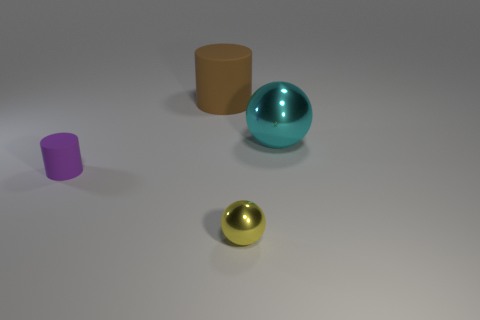There is another rubber object that is the same shape as the brown rubber thing; what size is it?
Provide a short and direct response. Small. There is another ball that is made of the same material as the cyan sphere; what color is it?
Offer a terse response. Yellow. Is there a green metal sphere of the same size as the purple rubber thing?
Your answer should be compact. No. Is the number of big metal objects behind the tiny yellow sphere greater than the number of yellow metal spheres right of the cyan sphere?
Give a very brief answer. Yes. Are the sphere that is on the left side of the cyan thing and the ball behind the small purple rubber cylinder made of the same material?
Provide a succinct answer. Yes. There is a thing that is the same size as the yellow metal ball; what shape is it?
Offer a terse response. Cylinder. Are there any other tiny objects that have the same shape as the cyan metal thing?
Make the answer very short. Yes. There is a tiny purple matte thing; are there any small yellow metallic objects behind it?
Your response must be concise. No. There is a object that is right of the brown rubber cylinder and behind the small yellow object; what is its material?
Provide a short and direct response. Metal. Does the cylinder in front of the brown object have the same material as the brown cylinder?
Provide a succinct answer. Yes. 